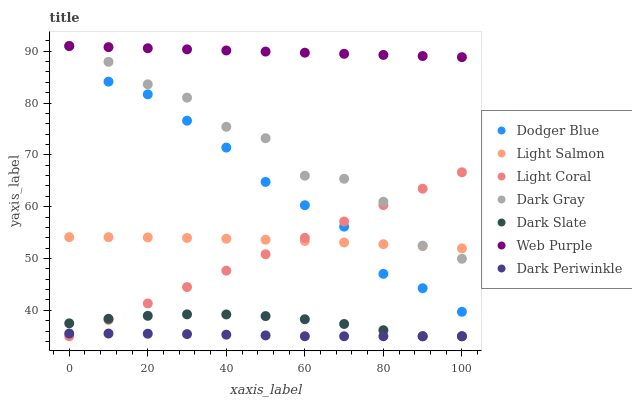Does Dark Periwinkle have the minimum area under the curve?
Answer yes or no. Yes. Does Web Purple have the maximum area under the curve?
Answer yes or no. Yes. Does Light Salmon have the minimum area under the curve?
Answer yes or no. No. Does Light Salmon have the maximum area under the curve?
Answer yes or no. No. Is Light Coral the smoothest?
Answer yes or no. Yes. Is Dark Gray the roughest?
Answer yes or no. Yes. Is Light Salmon the smoothest?
Answer yes or no. No. Is Light Salmon the roughest?
Answer yes or no. No. Does Light Coral have the lowest value?
Answer yes or no. Yes. Does Light Salmon have the lowest value?
Answer yes or no. No. Does Dodger Blue have the highest value?
Answer yes or no. Yes. Does Light Salmon have the highest value?
Answer yes or no. No. Is Dark Periwinkle less than Dodger Blue?
Answer yes or no. Yes. Is Dark Gray greater than Dark Periwinkle?
Answer yes or no. Yes. Does Dodger Blue intersect Dark Gray?
Answer yes or no. Yes. Is Dodger Blue less than Dark Gray?
Answer yes or no. No. Is Dodger Blue greater than Dark Gray?
Answer yes or no. No. Does Dark Periwinkle intersect Dodger Blue?
Answer yes or no. No. 